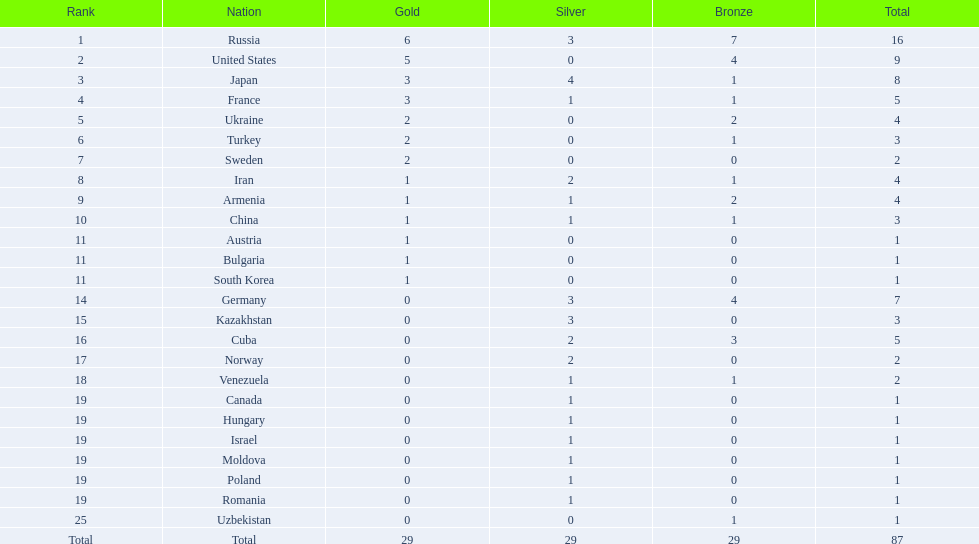What nations hold one gold award? Iran, Armenia, China, Austria, Bulgaria, South Korea. Could you help me parse every detail presented in this table? {'header': ['Rank', 'Nation', 'Gold', 'Silver', 'Bronze', 'Total'], 'rows': [['1', 'Russia', '6', '3', '7', '16'], ['2', 'United States', '5', '0', '4', '9'], ['3', 'Japan', '3', '4', '1', '8'], ['4', 'France', '3', '1', '1', '5'], ['5', 'Ukraine', '2', '0', '2', '4'], ['6', 'Turkey', '2', '0', '1', '3'], ['7', 'Sweden', '2', '0', '0', '2'], ['8', 'Iran', '1', '2', '1', '4'], ['9', 'Armenia', '1', '1', '2', '4'], ['10', 'China', '1', '1', '1', '3'], ['11', 'Austria', '1', '0', '0', '1'], ['11', 'Bulgaria', '1', '0', '0', '1'], ['11', 'South Korea', '1', '0', '0', '1'], ['14', 'Germany', '0', '3', '4', '7'], ['15', 'Kazakhstan', '0', '3', '0', '3'], ['16', 'Cuba', '0', '2', '3', '5'], ['17', 'Norway', '0', '2', '0', '2'], ['18', 'Venezuela', '0', '1', '1', '2'], ['19', 'Canada', '0', '1', '0', '1'], ['19', 'Hungary', '0', '1', '0', '1'], ['19', 'Israel', '0', '1', '0', '1'], ['19', 'Moldova', '0', '1', '0', '1'], ['19', 'Poland', '0', '1', '0', '1'], ['19', 'Romania', '0', '1', '0', '1'], ['25', 'Uzbekistan', '0', '0', '1', '1'], ['Total', 'Total', '29', '29', '29', '87']]} From these, which nations have zero silver awards? Austria, Bulgaria, South Korea. From these, which nations also don't own any bronze awards? Austria. 